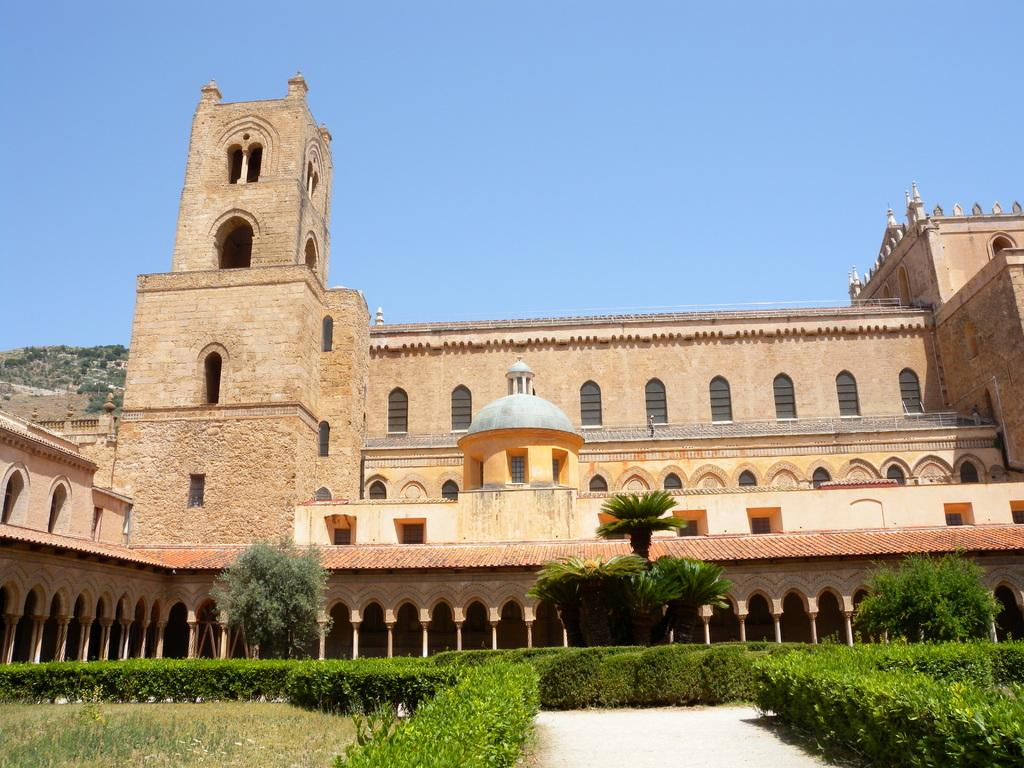What type of structure is visible in the image? There is a fort in the image. What is located in front of the fort? There is a beautiful garden in front of the fort. What can be found in the garden? The garden contains trees and plants. What type of pear is hanging from the trees in the garden? There is no pear present in the image; the garden contains trees and plants, but no specific fruit is mentioned. 